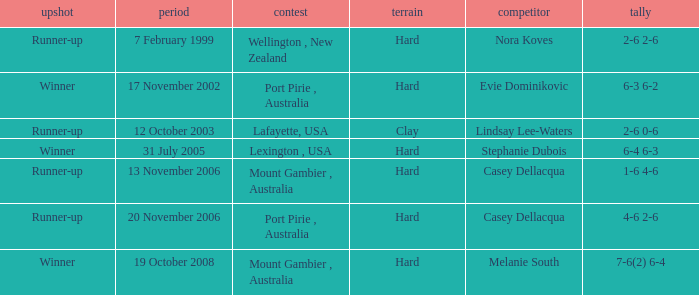When is an Opponent of evie dominikovic? 17 November 2002. 